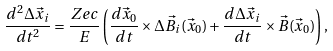<formula> <loc_0><loc_0><loc_500><loc_500>\frac { d ^ { 2 } \Delta \vec { x } _ { i } } { d t ^ { 2 } } = \frac { Z e c } { E } \left ( \frac { d \vec { x } _ { 0 } } { d t } \times \Delta \vec { B } _ { i } ( \vec { x } _ { 0 } ) + \frac { d \Delta \vec { x } _ { i } } { d t } \times \vec { B } ( \vec { x } _ { 0 } ) \right ) ,</formula> 